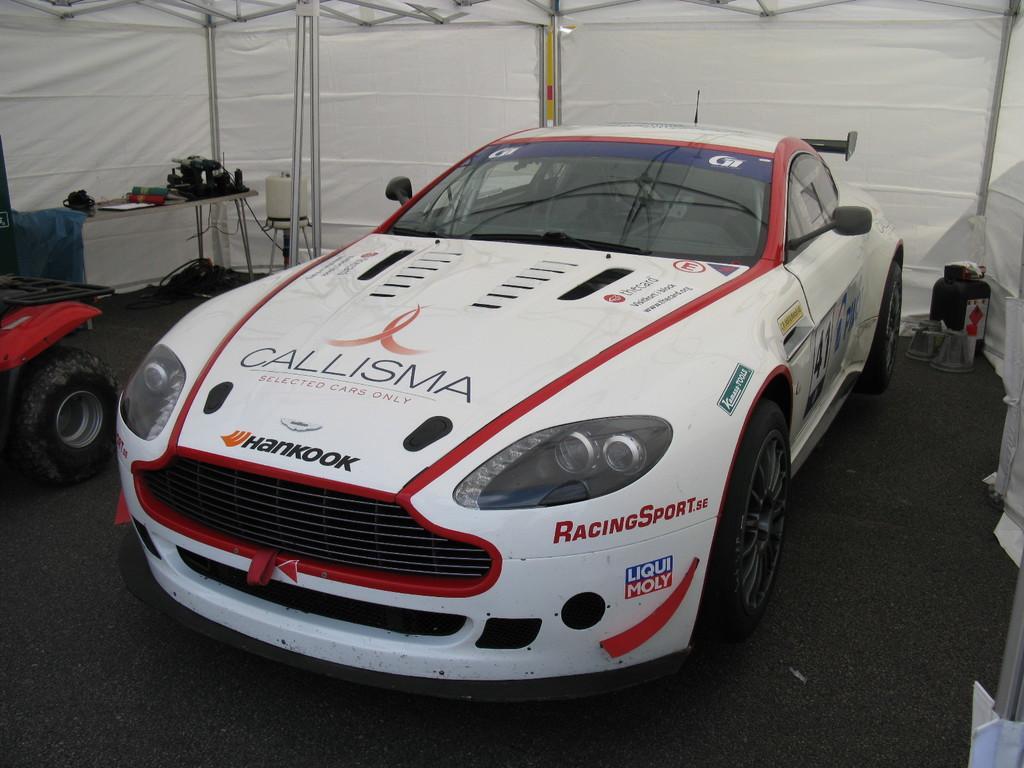How would you summarize this image in a sentence or two? In this image we can see a white red color car, behind the car white color white color tint is their and one table is there. on the top of the table some things are kept. Right side of the image one black color thing is present. Left side of the image one vehicle is there. 